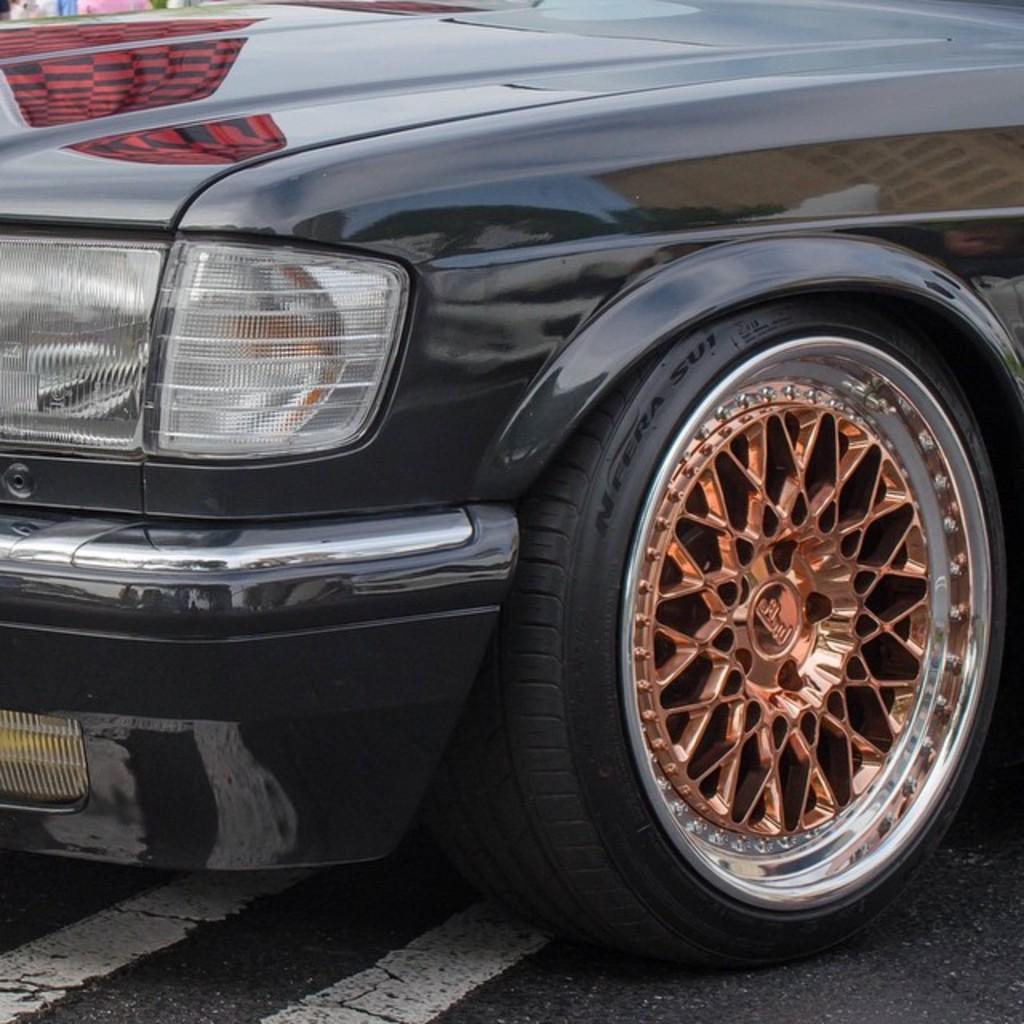Please provide a concise description of this image. In the center of the image there is a car. At the bottom of the image there is road. 